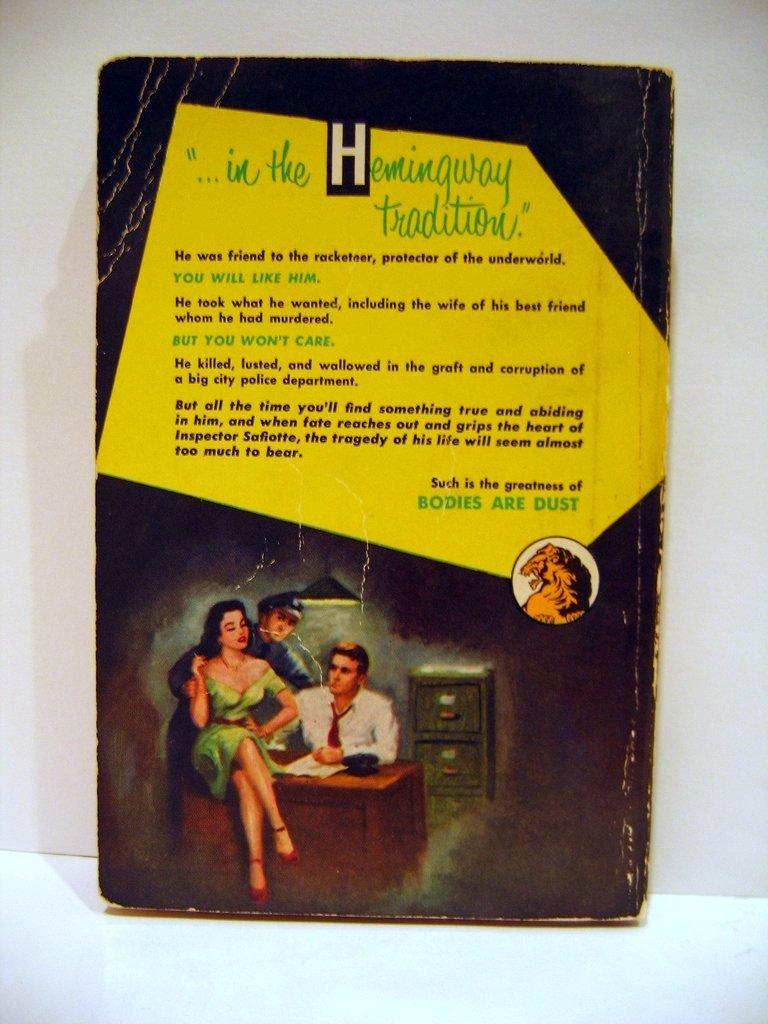<image>
Provide a brief description of the given image. The back of a book that reads "...in the Hemingway tradition." 